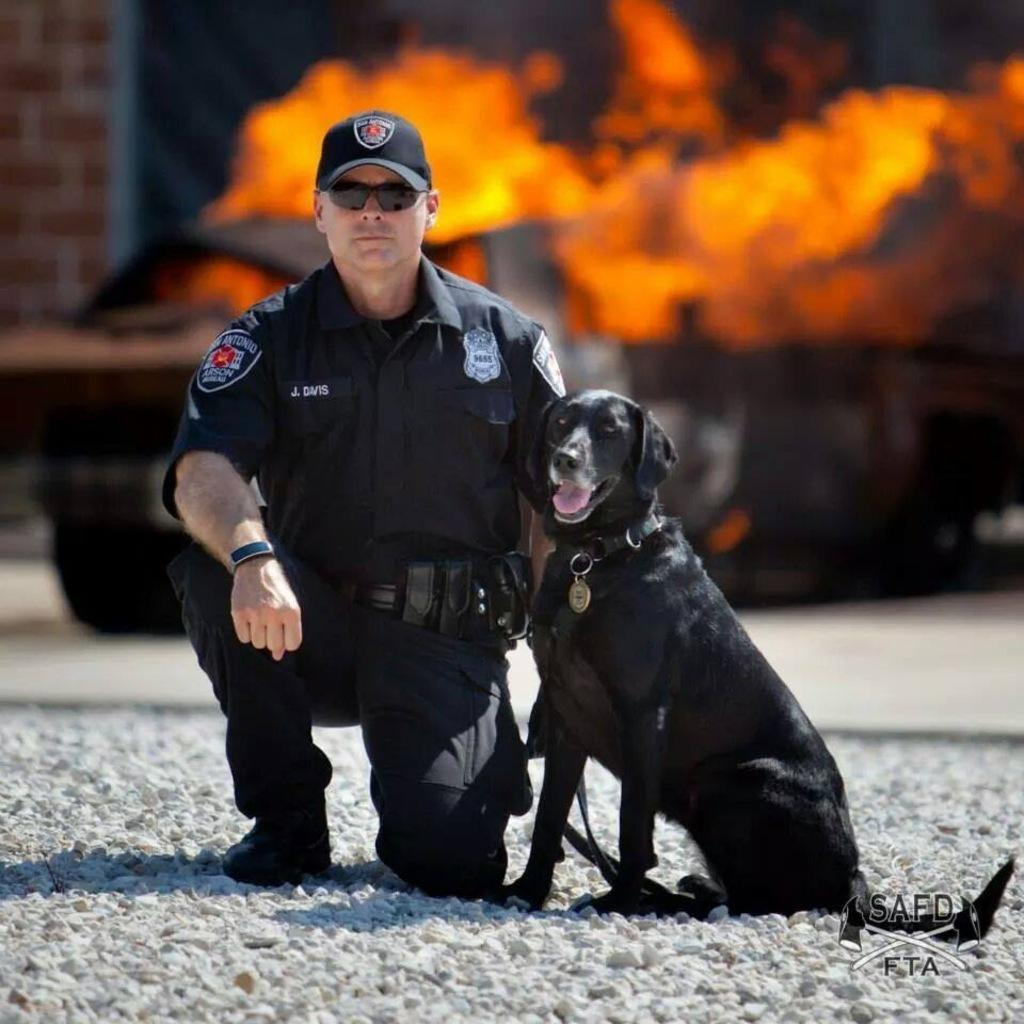What is the main subject in the middle of the image? There is a man sitting in the middle of the image. What is located beside the man? There is a dog beside the man. What can be seen behind the man and the dog? There is a flame visible behind the man and the dog. What is present in the top left side of the image? There is a wall in the top left side of the image. What hobbies does the visitor engage in while using the lift in the image? There is no visitor or lift present in the image; it features a man, a dog, a flame, and a wall. 